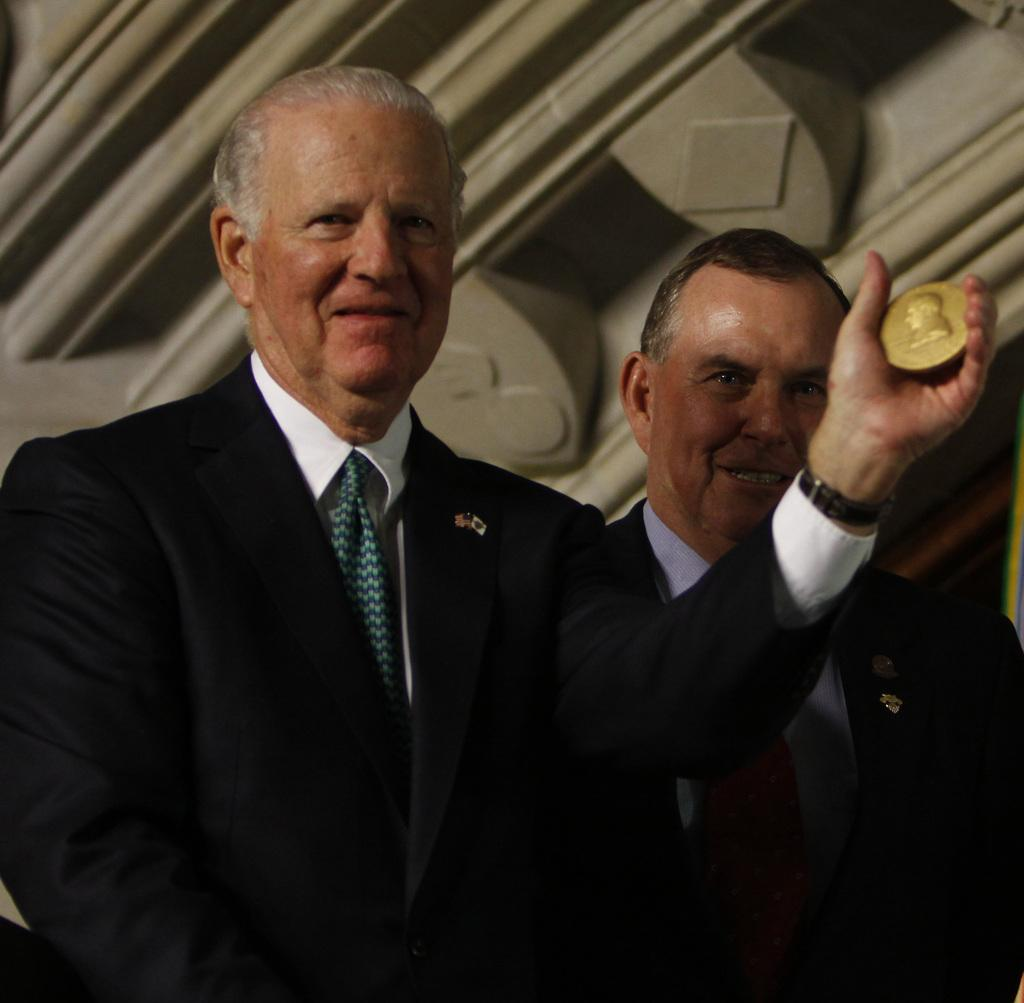How many people are in the image? There are two men in the image. What is one of the men holding in his hand? There is a man holding an object in his hand. What type of roof is visible in the image? There is a metal roof visible in the image. What type of plantation is visible in the image? There is no plantation visible in the image. What is the name of the governor in the image? There is no governor present in the image. 